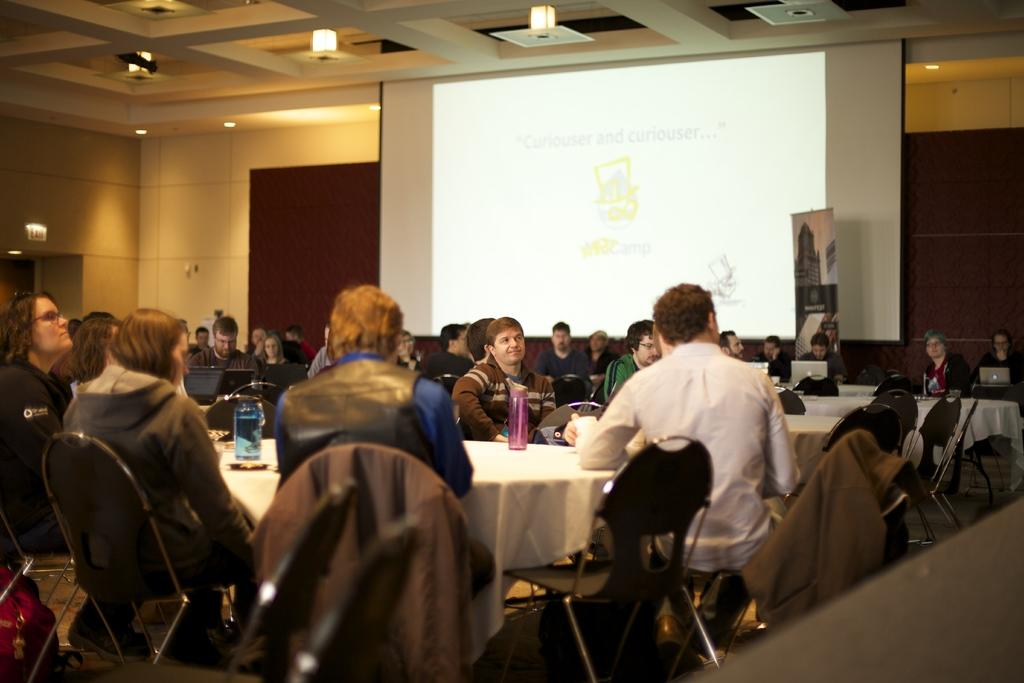Who or what is present in the image? There are people in the image. What are the people doing in the image? The people are seated on chairs. What else can be seen in the image besides the people? There is a projector screen in the image. What level of experience do the people have with the projector in the image? There is no indication of the people's experience level with the projector in the image. How much wealth is displayed on the projector screen in the image? There is no indication of wealth being displayed on the projector screen in the image. 